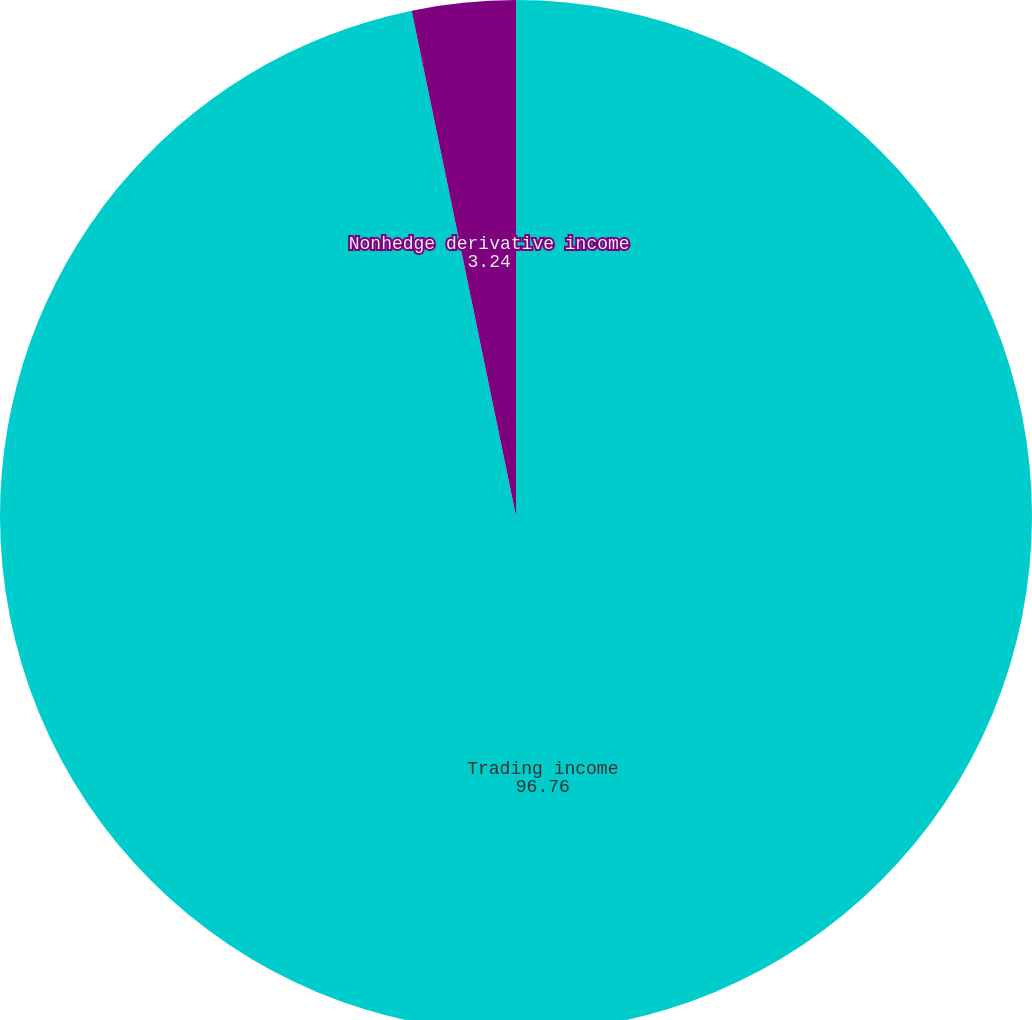Convert chart. <chart><loc_0><loc_0><loc_500><loc_500><pie_chart><fcel>Trading income<fcel>Nonhedge derivative income<nl><fcel>96.76%<fcel>3.24%<nl></chart> 